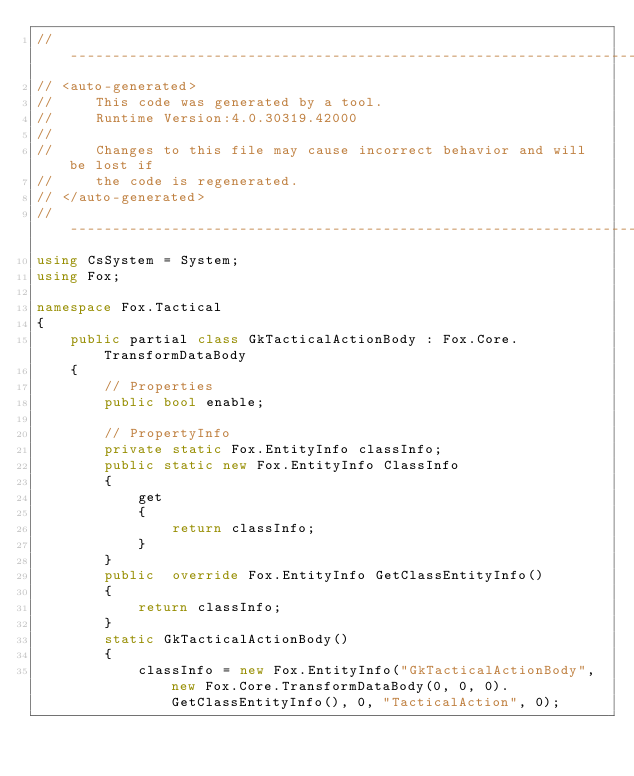<code> <loc_0><loc_0><loc_500><loc_500><_C#_>//------------------------------------------------------------------------------
// <auto-generated>
//     This code was generated by a tool.
//     Runtime Version:4.0.30319.42000
//
//     Changes to this file may cause incorrect behavior and will be lost if
//     the code is regenerated.
// </auto-generated>
//------------------------------------------------------------------------------
using CsSystem = System;
using Fox;

namespace Fox.Tactical
{
    public partial class GkTacticalActionBody : Fox.Core.TransformDataBody 
    {
        // Properties
        public bool enable;
        
        // PropertyInfo
        private static Fox.EntityInfo classInfo;
        public static new Fox.EntityInfo ClassInfo
        {
            get
            {
                return classInfo;
            }
        }
        public  override Fox.EntityInfo GetClassEntityInfo()
        {
            return classInfo;
        }
        static GkTacticalActionBody()
        {
            classInfo = new Fox.EntityInfo("GkTacticalActionBody", new Fox.Core.TransformDataBody(0, 0, 0).GetClassEntityInfo(), 0, "TacticalAction", 0);
			</code> 